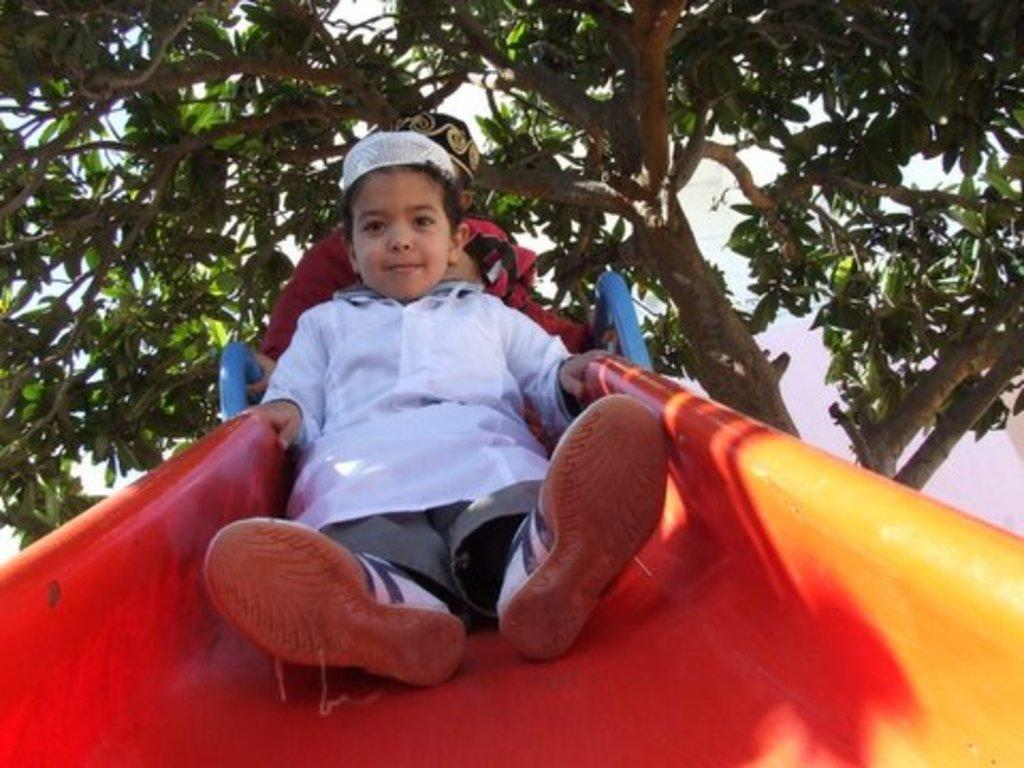How many children are in the image? There are two children in the image. What are the children doing in the image? The children are on a slide. What can be seen in the background of the image? There is a tree visible in the background of the image. What type of exchange is taking place between the children and the volcano in the image? There is no volcano present in the image, and therefore no exchange can be observed between the children and a volcano. 